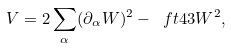Convert formula to latex. <formula><loc_0><loc_0><loc_500><loc_500>V = 2 \sum _ { \alpha } ( \partial _ { \alpha } W ) ^ { 2 } - \ f t 4 3 W ^ { 2 } ,</formula> 